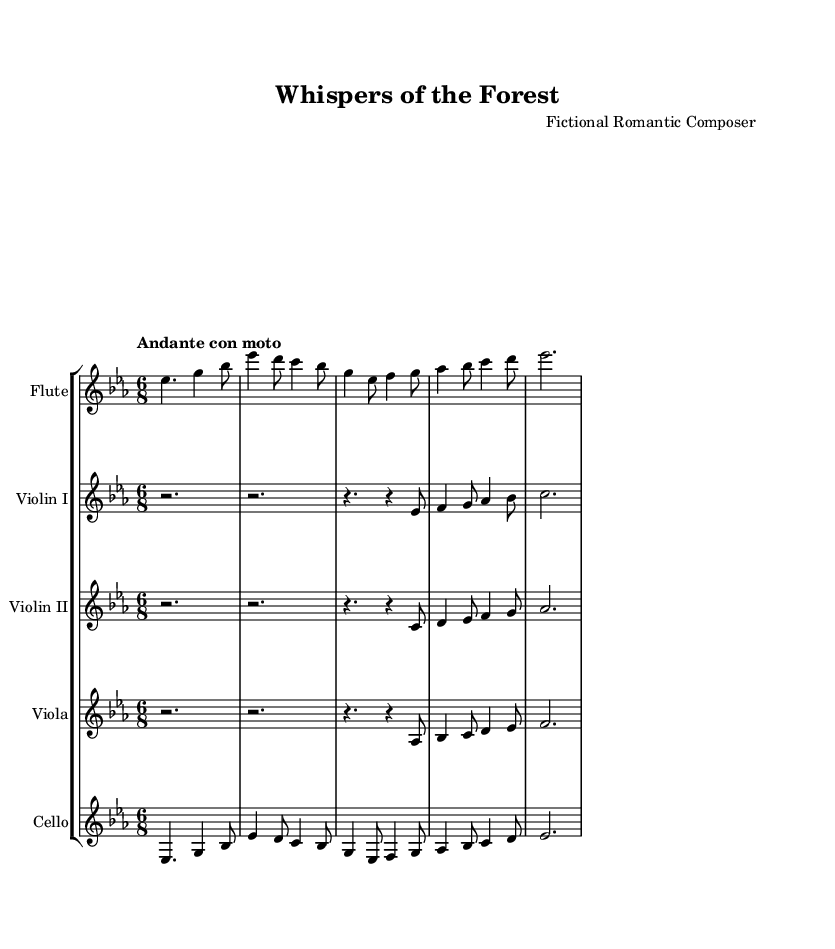What is the key signature of this music? The key signature is determined by looking at the symbols at the beginning of the staff. It shows three flats, indicating it is in E flat major.
Answer: E flat major What is the time signature of this music? The time signature is located at the beginning of the staff, represented by the numbers 6 and 8, indicating that there are six beats in a measure and the eighth note gets the beat.
Answer: 6/8 What is the tempo marking for this piece? The tempo is specified above the staff, where it states "Andante con moto," indicating a moderately slow tempo with some motion.
Answer: Andante con moto How many measures are in the flute part? To determine the number of measures, the music must be counted from the beginning to the last bar line of the flute part. There are a total of five measures in the flute music.
Answer: 5 What instruments are included in this score? The instruments can be identified by the instrument names provided for each staff. The score includes Flute, Violin I, Violin II, Viola, and Cello.
Answer: Flute, Violin I, Violin II, Viola, Cello What prominent theme is reflected in this Romantic era piece? The title "Whispers of the Forest" suggests themes of nature and the sublime, common in Romantic music, often evoking emotional responses through musical imagery.
Answer: Nature and sublime What is the texture of the music in this score? The different instrument parts suggest a polyphonic texture, as multiple voices harmonize and interact, which is characteristic of Romantic symphonies with rich orchestral textures.
Answer: Polyphonic 